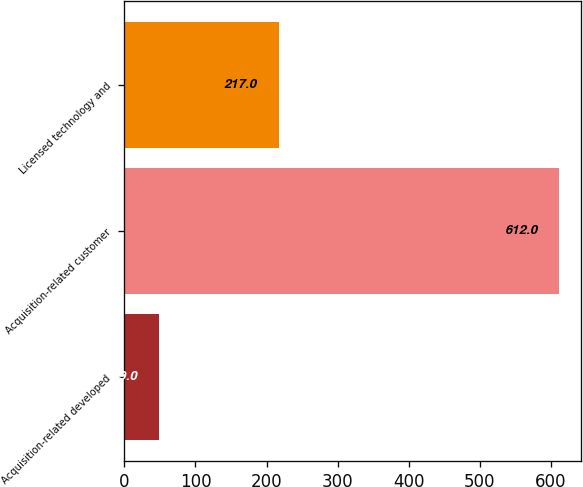Convert chart to OTSL. <chart><loc_0><loc_0><loc_500><loc_500><bar_chart><fcel>Acquisition-related developed<fcel>Acquisition-related customer<fcel>Licensed technology and<nl><fcel>49<fcel>612<fcel>217<nl></chart> 